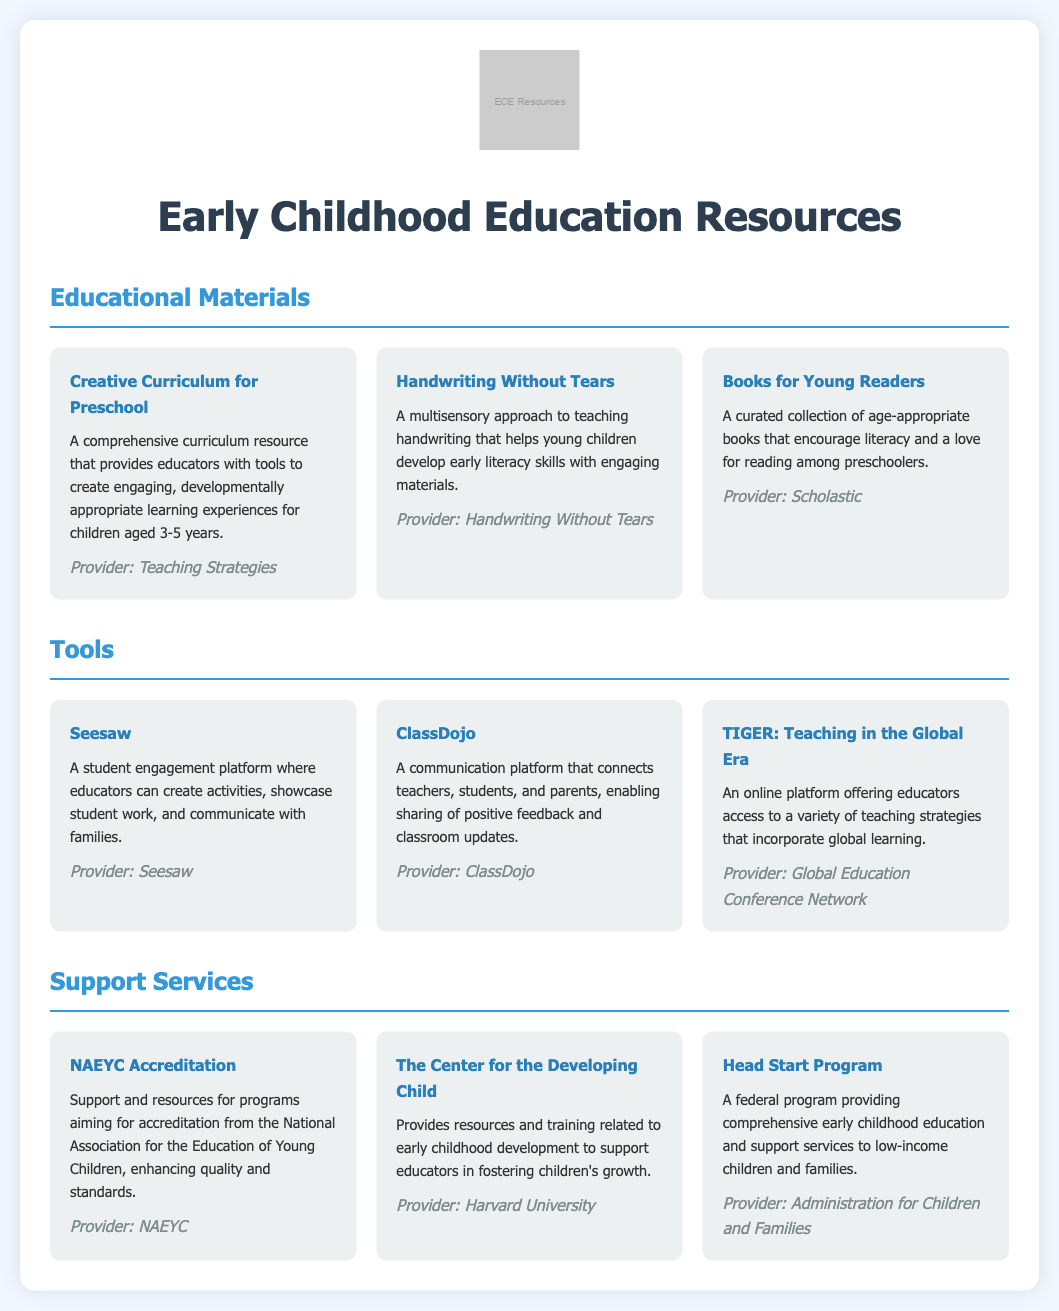What is the name of the comprehensive curriculum resource? The comprehensive curriculum resource mentioned is "Creative Curriculum for Preschool."
Answer: Creative Curriculum for Preschool Who provides the "Handwriting Without Tears" resource? "Handwriting Without Tears" is provided by Handwriting Without Tears.
Answer: Handwriting Without Tears What tool enables communication between teachers, students, and parents? The tool that enables this communication is "ClassDojo."
Answer: ClassDojo Which organization provides support for NAEYC Accreditation? The provider for NAEYC Accreditation support is NAEYC.
Answer: NAEYC How many resources are listed under Educational Materials? There are three resources listed under Educational Materials.
Answer: 3 What is the focus of the Head Start Program? The focus of the Head Start Program is to provide comprehensive early childhood education and support services.
Answer: Early childhood education and support services Which educational tool is a student engagement platform? The student engagement platform mentioned is "Seesaw."
Answer: Seesaw What type of services does "The Center for the Developing Child" provide? "The Center for the Developing Child" provides resources and training related to early childhood development.
Answer: Resources and training Which company provides the "TIGER: Teaching in the Global Era" platform? The provider of the "TIGER: Teaching in the Global Era" platform is the Global Education Conference Network.
Answer: Global Education Conference Network 